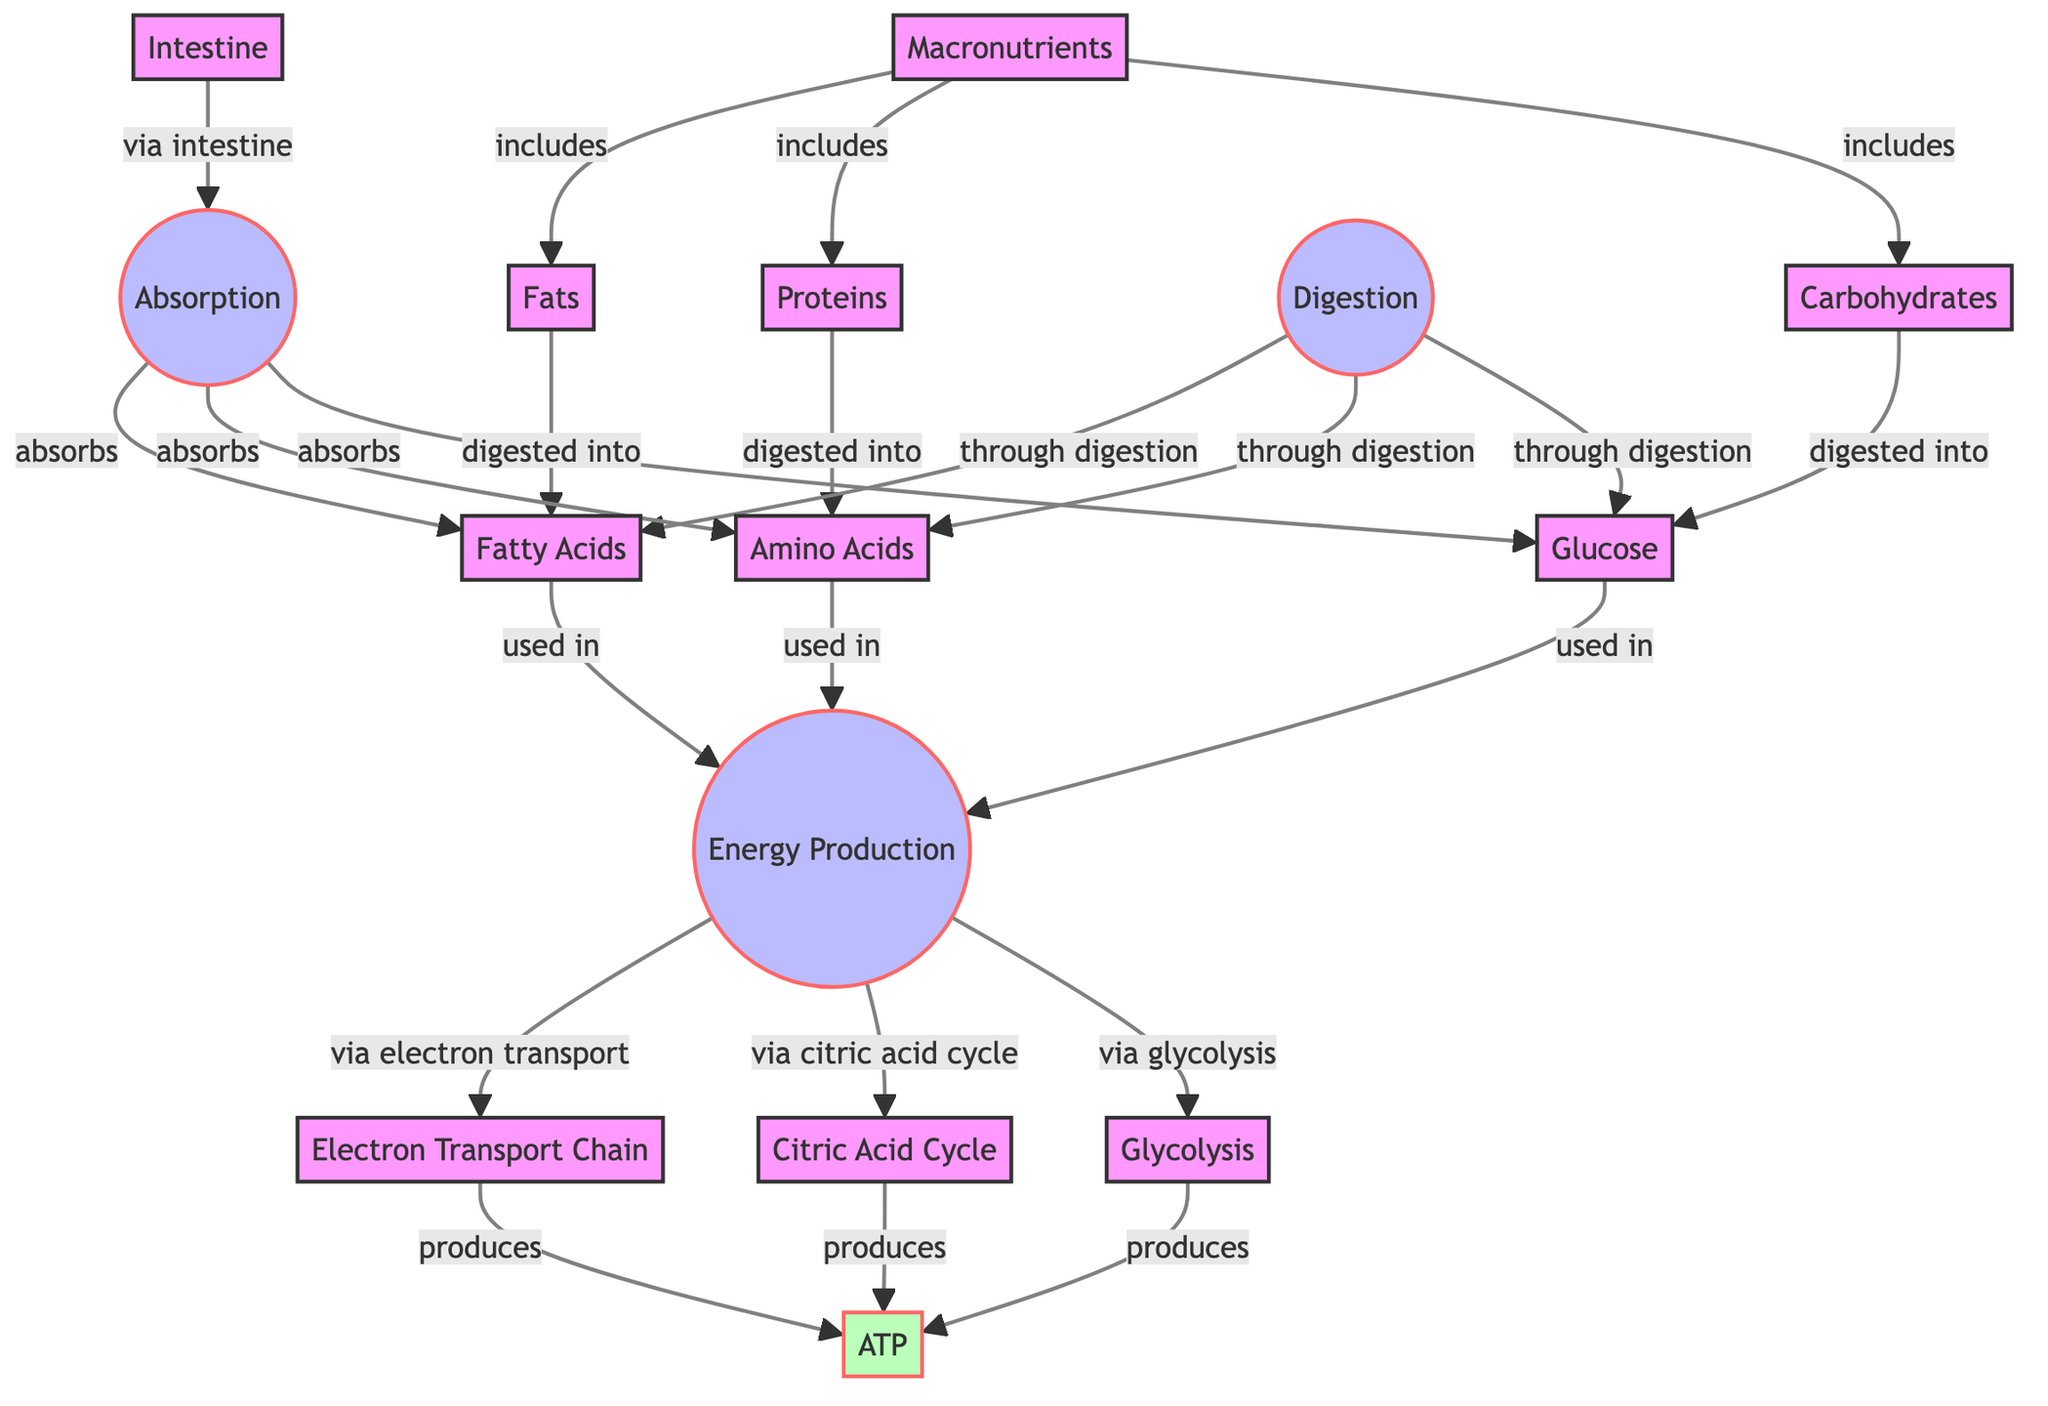What are the three types of macronutrients included in the diagram? The diagram lists carbohydrates, proteins, and fats as the three macronutrients included under the "Macronutrients" node.
Answer: Carbohydrates, Proteins, Fats What is produced by glycolysis? Glycolysis is connected to ATP production in the diagram. Therefore, it produces ATP as a result of energy metabolism.
Answer: ATP How many processes are shown in the diagram? The diagram outlines three processes: Digestion, Absorption, and Energy Production. Counting these three processes provides the answer.
Answer: 3 Which nutrient is digested into glucose? The diagram indicates that carbohydrates are digested into glucose, as represented by the directed arrow from carbohydrates to glucose.
Answer: Glucose What process absorbs fatty acids? The digestion and absorption processes lead to the absorption of fatty acids; therefore, the Absorption process is the answer.
Answer: Absorption Which node is located after the Absorption process? The Absorption process leads to the Energy Production node, as shown in the diagram. Therefore, the node located after Absorption is Energy Production.
Answer: Energy Production What do the outputs of glycolysis and the citric acid cycle produce? Both glycolysis and the citric acid cycle lead to the production of ATP, as indicated by the arrows that connect them to the ATP node. Therefore, the output produced by both processes is ATP.
Answer: ATP What is the final energy molecule produced in the processes outlined? The final energy molecule indicated in the diagram, after going through glycolysis, citric acid cycle, and electron transport chain, is ATP.
Answer: ATP 